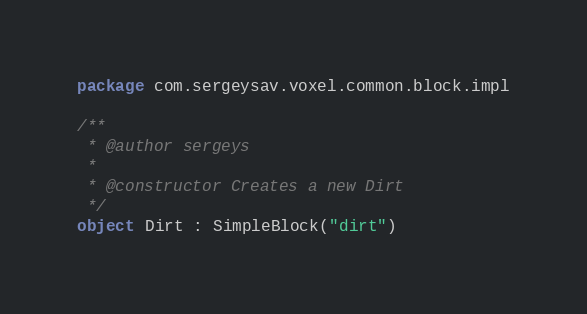<code> <loc_0><loc_0><loc_500><loc_500><_Kotlin_>package com.sergeysav.voxel.common.block.impl

/**
 * @author sergeys
 *
 * @constructor Creates a new Dirt
 */
object Dirt : SimpleBlock("dirt")
</code> 